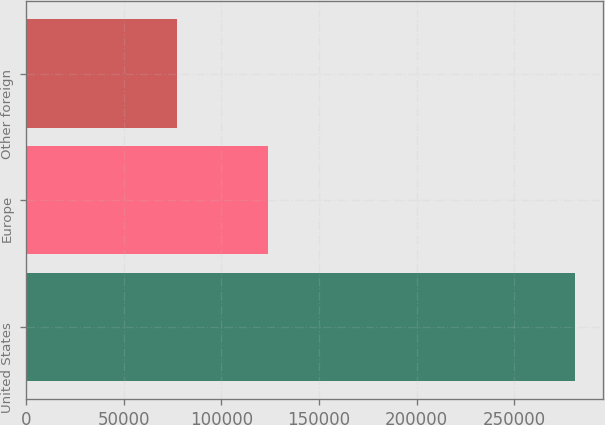Convert chart. <chart><loc_0><loc_0><loc_500><loc_500><bar_chart><fcel>United States<fcel>Europe<fcel>Other foreign<nl><fcel>281139<fcel>123996<fcel>77516<nl></chart> 